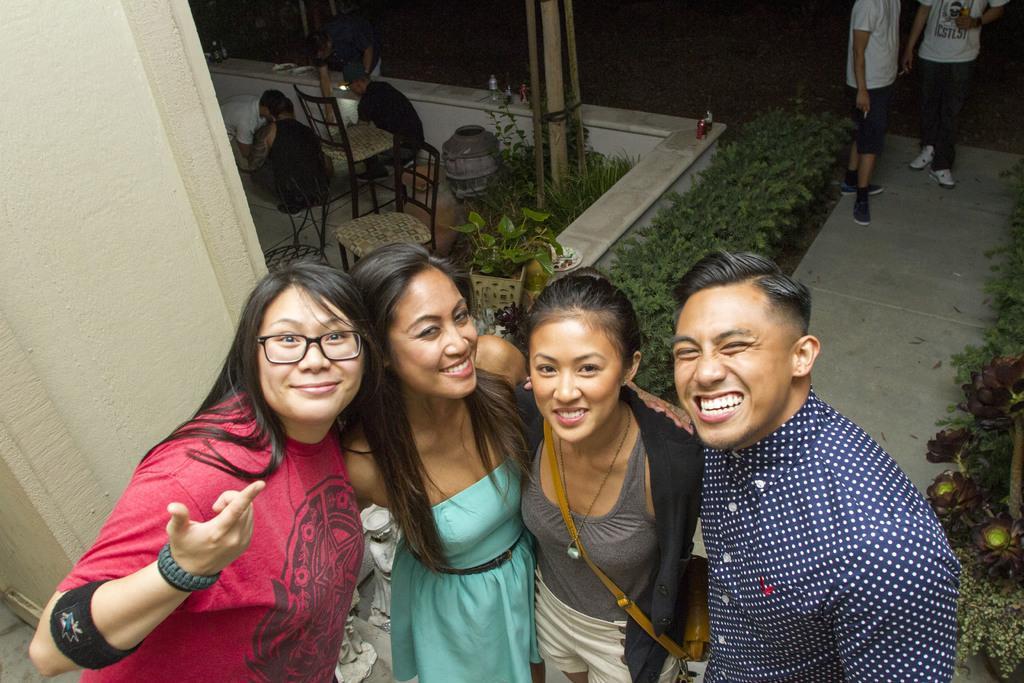Can you describe this image briefly? In the middle of the image few people are standing and smiling. Behind them there are some plants and chairs and poles and few people are standing and sitting. 